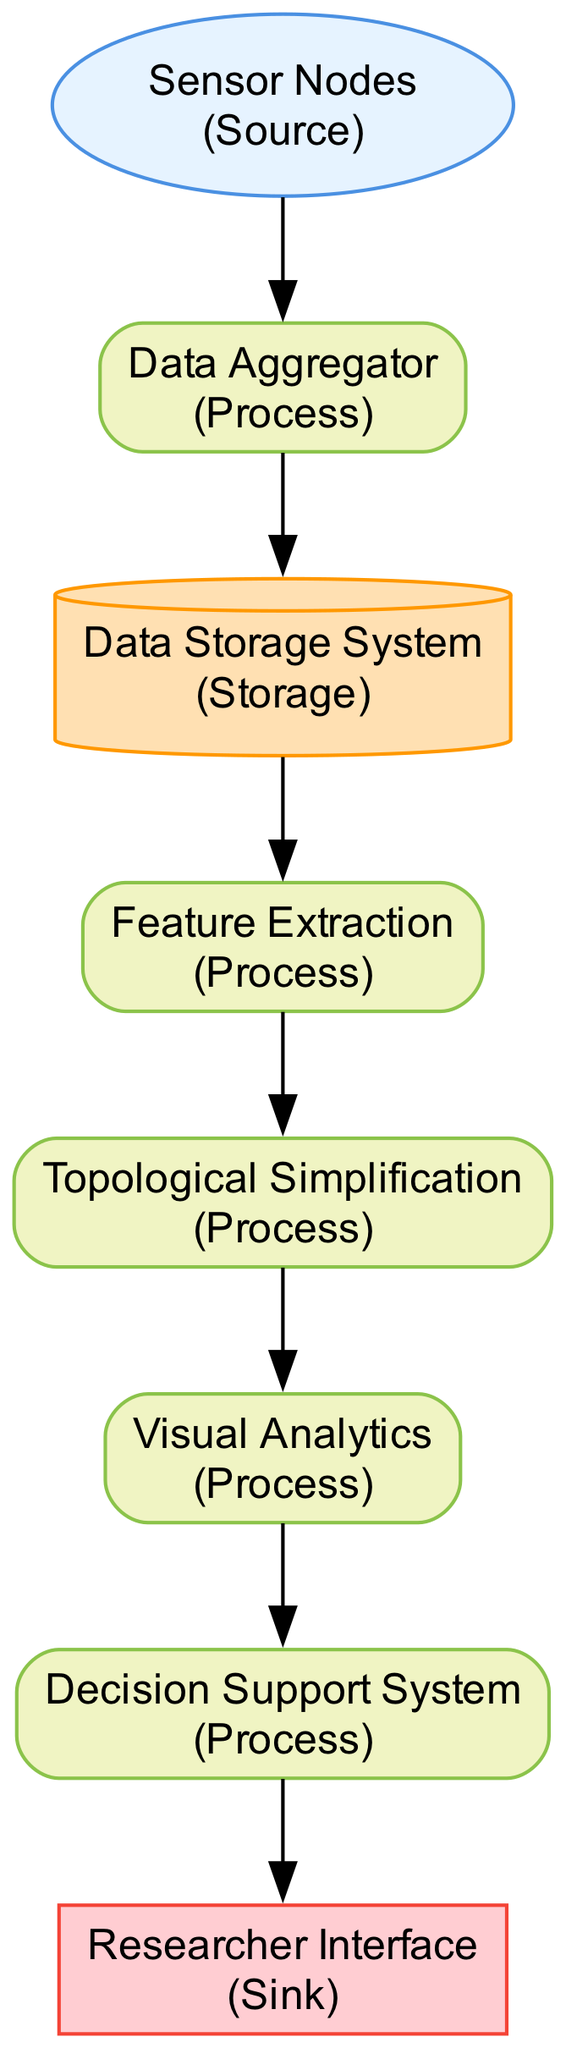What are the types of elements present in the diagram? The diagram includes four types of elements: Source, Process, Storage, and Sink. These can be identified through their styles and roles in the flow.
Answer: Source, Process, Storage, Sink How many nodes are there in total? By counting each unique node listed in the diagram, we find there are eight nodes in total.
Answer: Eight What process follows the Data Aggregator? Looking at the flow from the Data Aggregator, we see it connects directly to the Data Storage System, identifying it as the next process in line.
Answer: Data Storage System Which node generates visual representations? The Visual Analytics node is responsible for generating visual representations, as indicated by its description in the diagram.
Answer: Visual Analytics What is the purpose of the Decision Support System? The Decision Support System utilizes topological features and analytics for making informed decisions, combining insights from previous processes.
Answer: Data-driven decisions How does data flow from the Feature Extraction to the next node? The data flows from Feature Extraction to Topological Simplification through a directed edge, indicating a straightforward transition in the processing sequence.
Answer: To Topological Simplification Which node serves as a data sink? In the diagram, the Researcher Interface acts as the sink since it is the final destination where data outputs are displayed for user interaction.
Answer: Researcher Interface What type of analysis is performed at the Topological Simplification stage? The analysis at this stage involves simplifying topological features, particularly using techniques like persistent homology to filter out irrelevant data.
Answer: Persistent homology Which nodes are designated as processes? The diagram indicates the following nodes as processes: Data Aggregator, Feature Extraction, Topological Simplification, Visual Analytics, and Decision Support System, all functioning in data transformation roles.
Answer: Five processes 